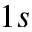Convert formula to latex. <formula><loc_0><loc_0><loc_500><loc_500>1 s</formula> 